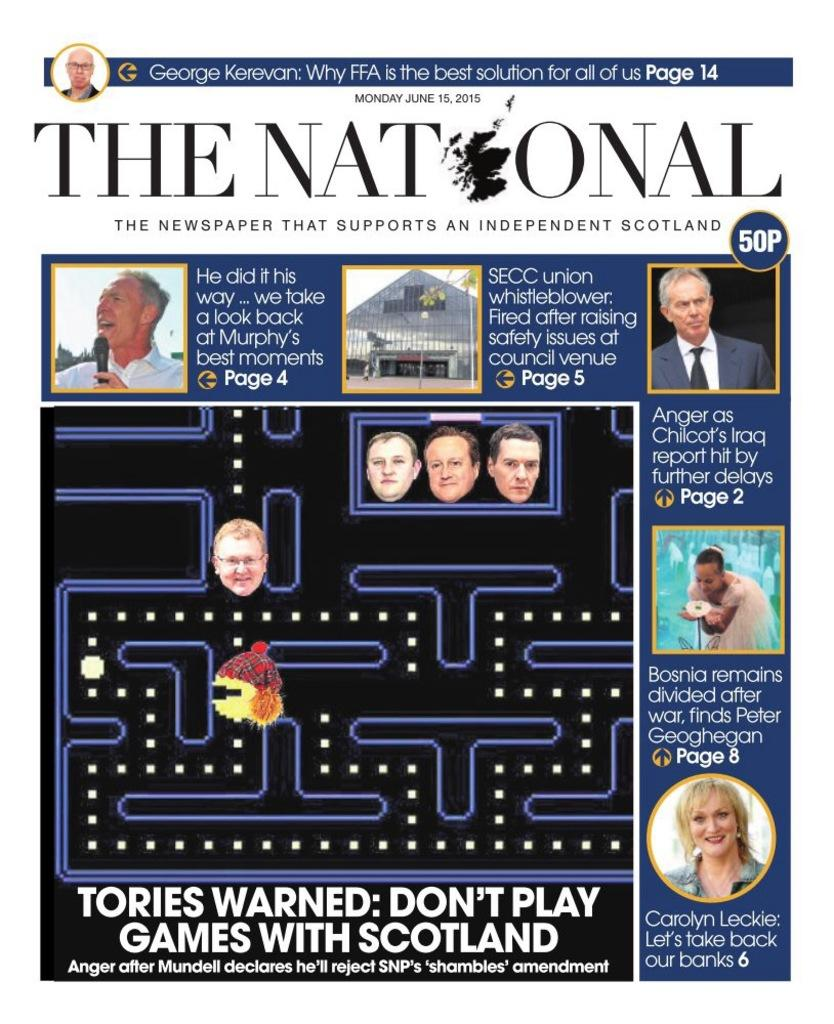What type of image is being described? The image is a poster. What is the main subject of the poster? There is a maze game depicted on the poster. Are there any written elements on the poster? Yes, there are texts written on the poster. Is there a specific title or heading on the poster? Yes, there is a heading on the poster. Are there any additional visual elements on the poster besides the maze game? Yes, there are small pictures on the poster. What type of education is being offered in the maze game on the poster? The maze game on the poster is not related to education; it is a game. How does the game on the poster affect the front of the poster? The game on the poster does not affect the front of the poster, as it is a depiction of the game within the poster's design. 